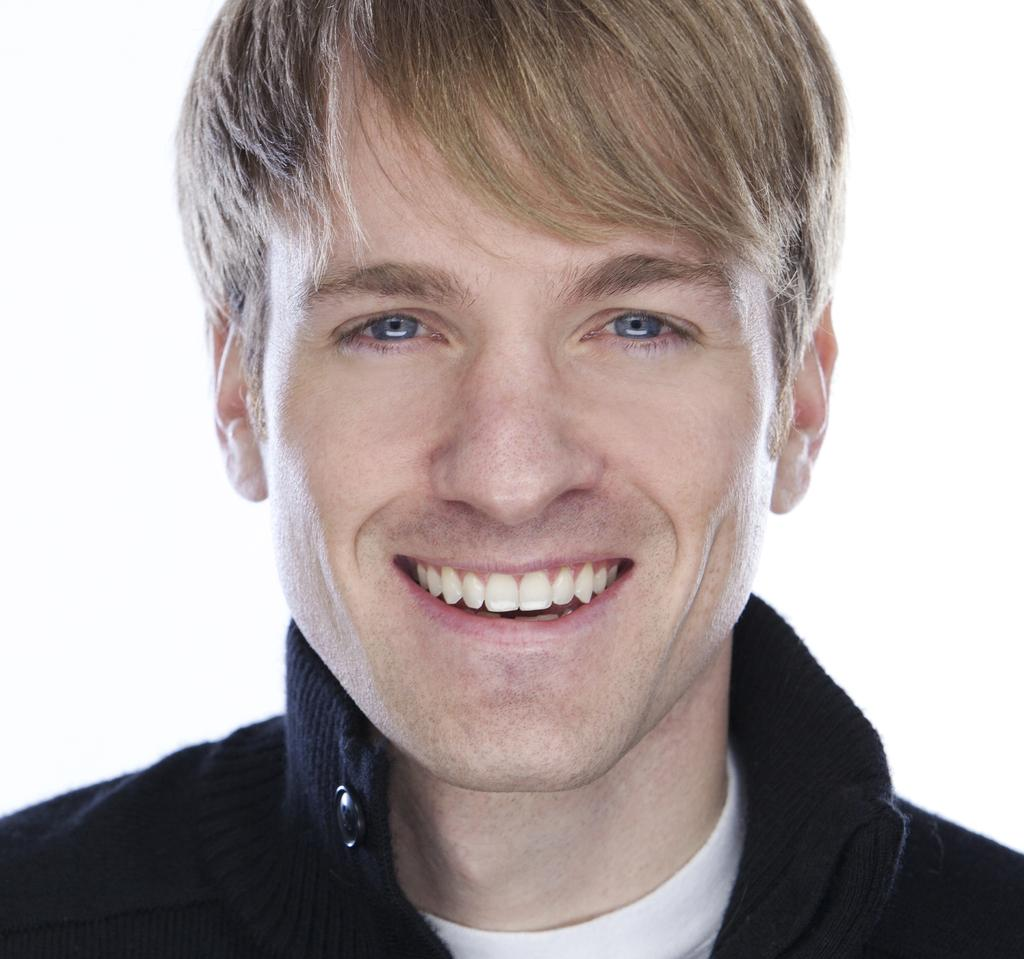What is the main subject of the image? There is a person in the image. Can you describe the person's hair color? The person has brown hair. What color is the background of the image? The background of the image is white. Can you tell me how many kittens are sitting on the person's lap in the image? There are no kittens present in the image. What is the person's afterthought after joining the group in the image? There is no indication of the person joining a group or having an afterthought in the image. 